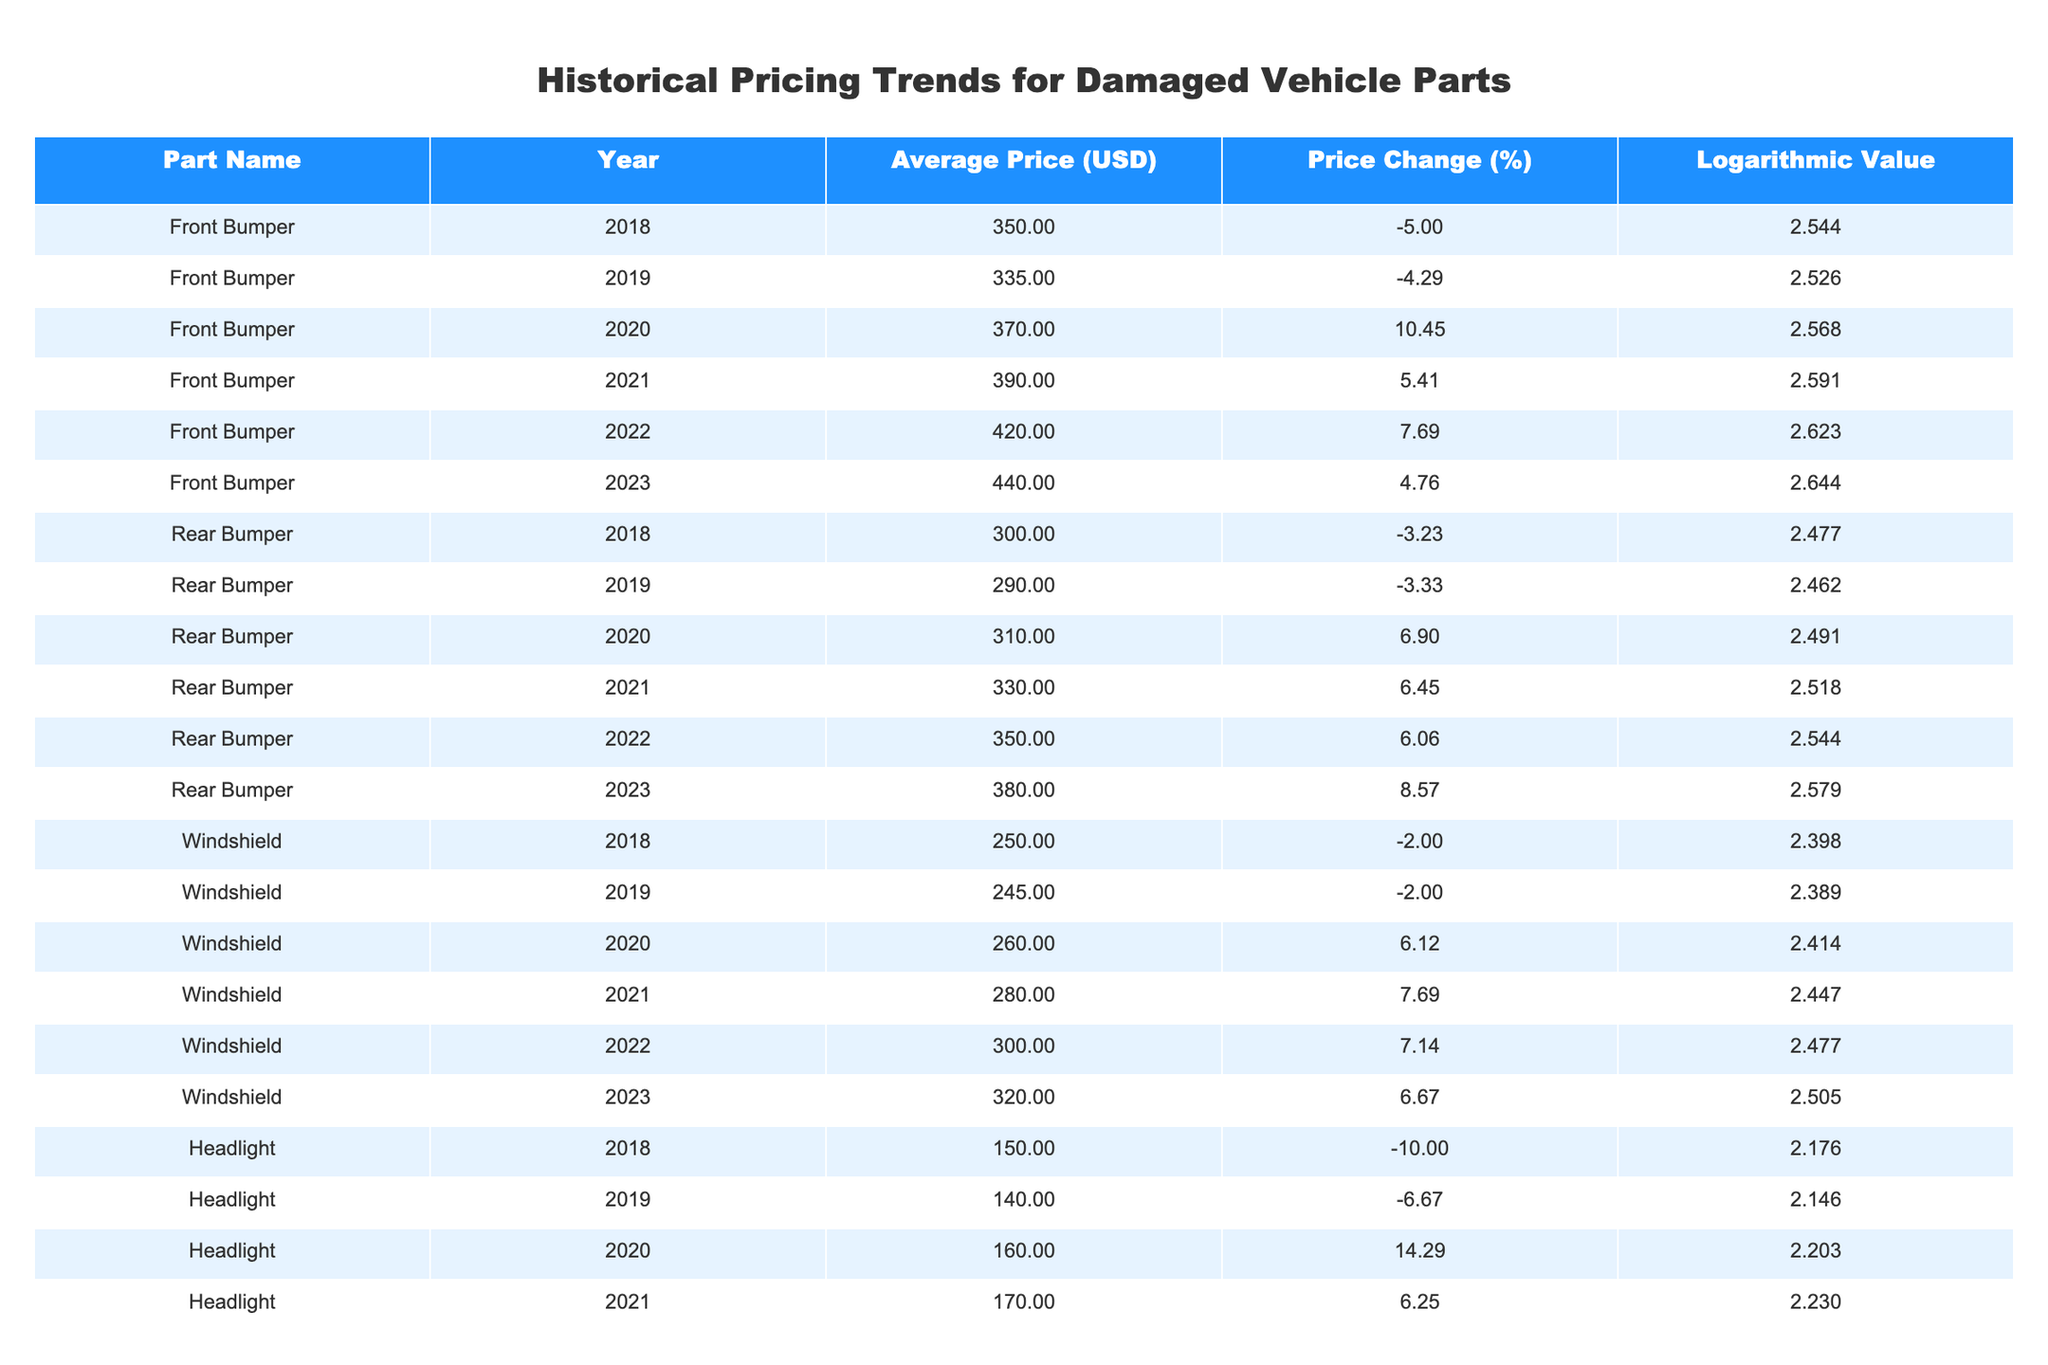What was the average price of the Front Bumper in 2021? The table shows that the average price of the Front Bumper in 2021 is listed as 390.00 USD directly in the relevant row.
Answer: 390.00 USD What percentage change did the Rear Bumper experience from 2020 to 2021? For the Rear Bumper, the price in 2020 was 310.00 USD and in 2021 it was 330.00 USD. The percentage change is calculated as ((330 - 310) / 310) * 100, which equals 6.45%.
Answer: 6.45% Was there an increase in the average price of the Windshield from 2018 to 2022? The average prices for the Windshield are 250.00 USD in 2018 and 300.00 USD in 2022. Since 300.00 is greater than 250.00, there was an increase.
Answer: Yes What is the average price of the Headlight over the years 2018 to 2023? The prices from 2018 to 2023 are 150.00, 140.00, 160.00, 170.00, 180.00, and 190.00 USD. Summing these gives 1090.00 USD, and dividing by 6 (the number of years) results in an average price of approximately 181.67 USD.
Answer: 181.67 USD Was the average price of the Taillight higher in 2023 than that of the Front Bumper in the same year? The average price of the Taillight in 2023 is 170.00 USD, while the average price of the Front Bumper in 2023 is 440.00 USD. Since 170.00 is less than 440.00, the statement is false.
Answer: No What was the total price change percentage for the Front Bumper from 2018 to 2023? The percentage changes from 2018 to 2023 for the Front Bumper are -5%, -4.29%, 10.45%, 5.41%, 7.69%, and 4.76%. The total changes can be calculated as (390.00 - 350.00) + (420.00 - 370.00) + (440.00 - 420.00), which sums to 90.00 USD, and as a percentage of the initial price (350.00) is (90/350) * 100 = 25.71%.
Answer: 25.71% 